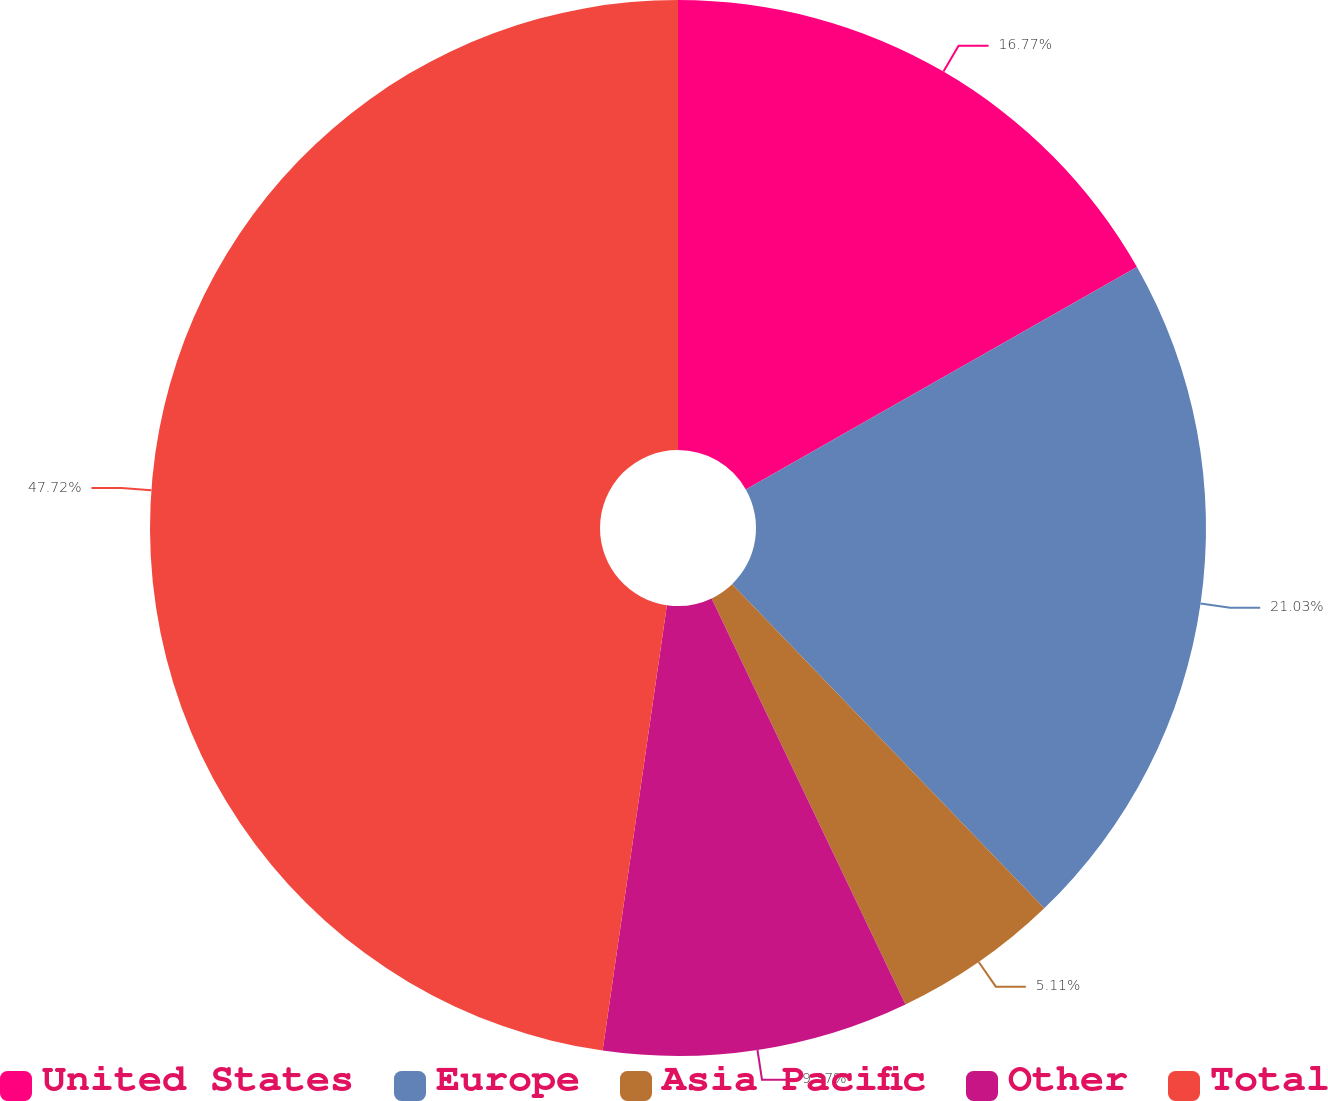Convert chart. <chart><loc_0><loc_0><loc_500><loc_500><pie_chart><fcel>United States<fcel>Europe<fcel>Asia Pacific<fcel>Other<fcel>Total<nl><fcel>16.77%<fcel>21.03%<fcel>5.11%<fcel>9.37%<fcel>47.72%<nl></chart> 